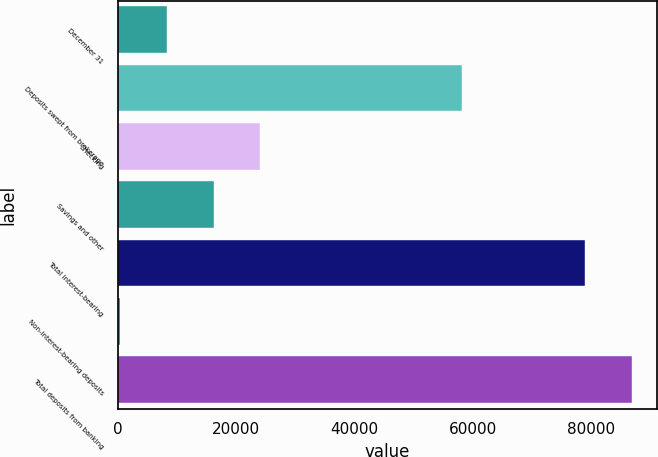Convert chart. <chart><loc_0><loc_0><loc_500><loc_500><bar_chart><fcel>December 31<fcel>Deposits swept from brokerage<fcel>Checking<fcel>Savings and other<fcel>Total interest-bearing<fcel>Non-interest-bearing deposits<fcel>Total deposits from banking<nl><fcel>8322<fcel>58229<fcel>24112<fcel>16217<fcel>78950<fcel>427<fcel>86845<nl></chart> 